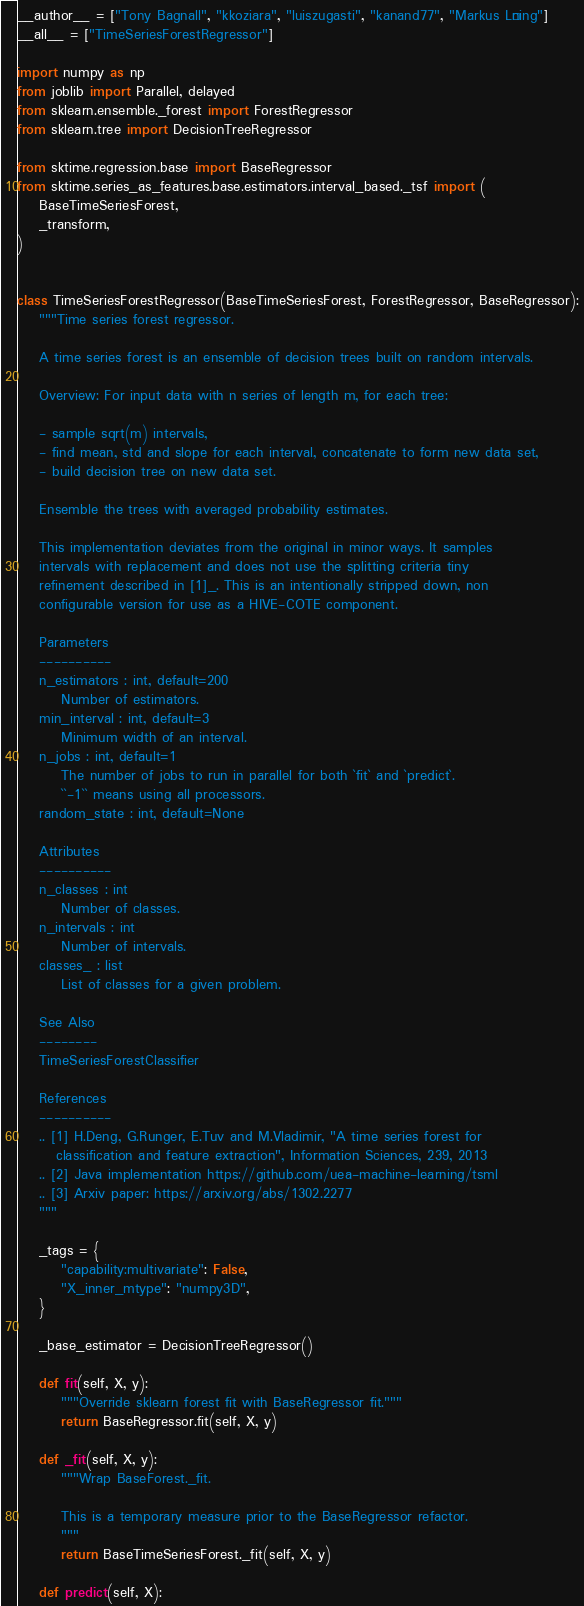<code> <loc_0><loc_0><loc_500><loc_500><_Python_>__author__ = ["Tony Bagnall", "kkoziara", "luiszugasti", "kanand77", "Markus Löning"]
__all__ = ["TimeSeriesForestRegressor"]

import numpy as np
from joblib import Parallel, delayed
from sklearn.ensemble._forest import ForestRegressor
from sklearn.tree import DecisionTreeRegressor

from sktime.regression.base import BaseRegressor
from sktime.series_as_features.base.estimators.interval_based._tsf import (
    BaseTimeSeriesForest,
    _transform,
)


class TimeSeriesForestRegressor(BaseTimeSeriesForest, ForestRegressor, BaseRegressor):
    """Time series forest regressor.

    A time series forest is an ensemble of decision trees built on random intervals.

    Overview: For input data with n series of length m, for each tree:

    - sample sqrt(m) intervals,
    - find mean, std and slope for each interval, concatenate to form new data set,
    - build decision tree on new data set.

    Ensemble the trees with averaged probability estimates.

    This implementation deviates from the original in minor ways. It samples
    intervals with replacement and does not use the splitting criteria tiny
    refinement described in [1]_. This is an intentionally stripped down, non
    configurable version for use as a HIVE-COTE component.

    Parameters
    ----------
    n_estimators : int, default=200
        Number of estimators.
    min_interval : int, default=3
        Minimum width of an interval.
    n_jobs : int, default=1
        The number of jobs to run in parallel for both `fit` and `predict`.
        ``-1`` means using all processors.
    random_state : int, default=None

    Attributes
    ----------
    n_classes : int
        Number of classes.
    n_intervals : int
        Number of intervals.
    classes_ : list
        List of classes for a given problem.

    See Also
    --------
    TimeSeriesForestClassifier

    References
    ----------
    .. [1] H.Deng, G.Runger, E.Tuv and M.Vladimir, "A time series forest for
       classification and feature extraction", Information Sciences, 239, 2013
    .. [2] Java implementation https://github.com/uea-machine-learning/tsml
    .. [3] Arxiv paper: https://arxiv.org/abs/1302.2277
    """

    _tags = {
        "capability:multivariate": False,
        "X_inner_mtype": "numpy3D",
    }

    _base_estimator = DecisionTreeRegressor()

    def fit(self, X, y):
        """Override sklearn forest fit with BaseRegressor fit."""
        return BaseRegressor.fit(self, X, y)

    def _fit(self, X, y):
        """Wrap BaseForest._fit.

        This is a temporary measure prior to the BaseRegressor refactor.
        """
        return BaseTimeSeriesForest._fit(self, X, y)

    def predict(self, X):</code> 